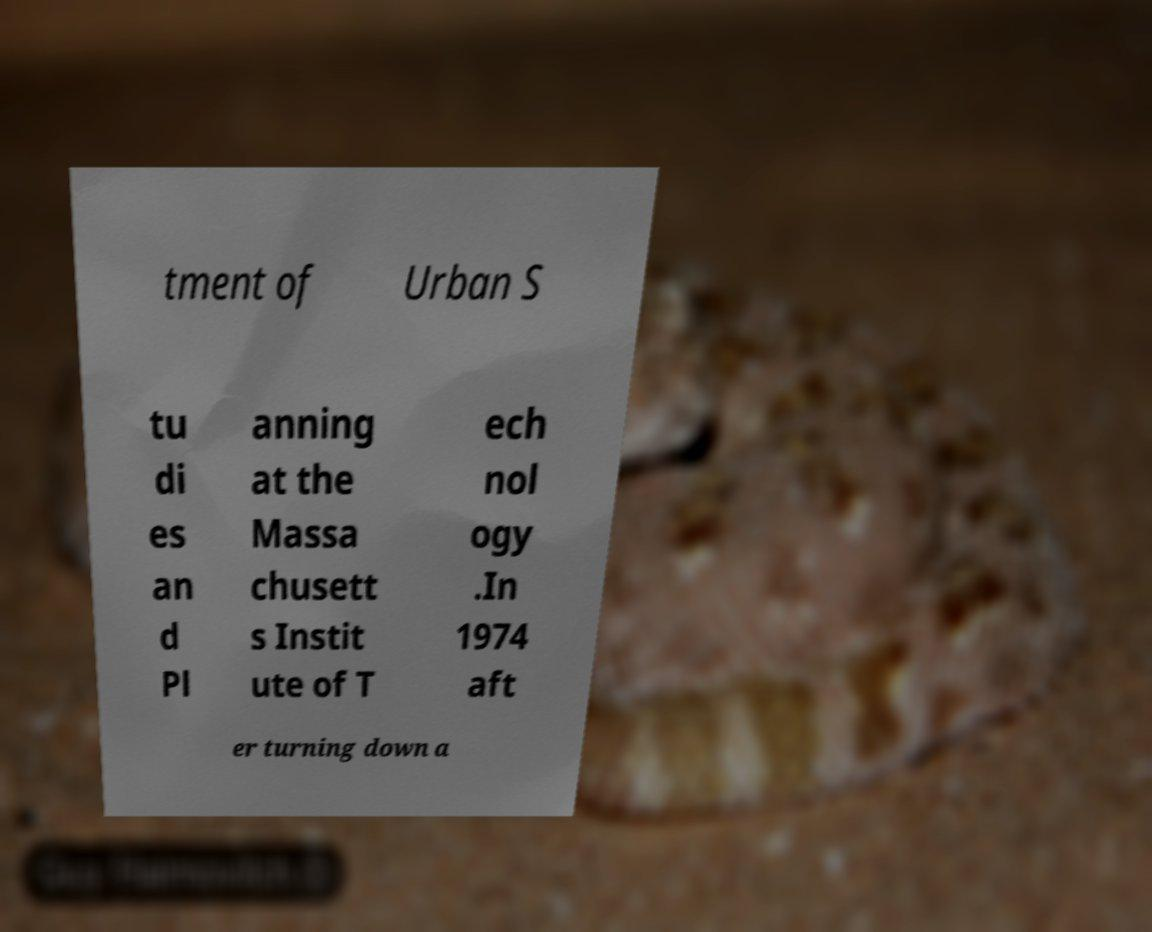Could you assist in decoding the text presented in this image and type it out clearly? tment of Urban S tu di es an d Pl anning at the Massa chusett s Instit ute of T ech nol ogy .In 1974 aft er turning down a 